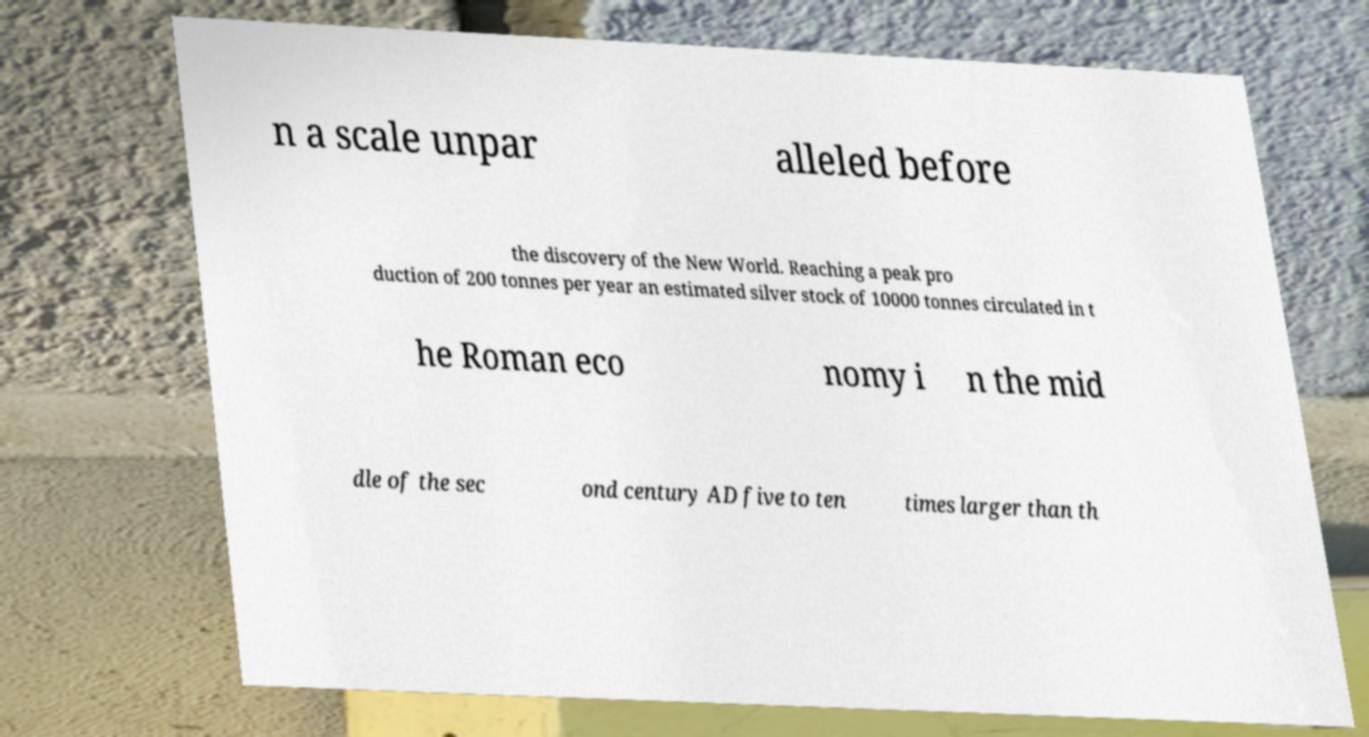There's text embedded in this image that I need extracted. Can you transcribe it verbatim? n a scale unpar alleled before the discovery of the New World. Reaching a peak pro duction of 200 tonnes per year an estimated silver stock of 10000 tonnes circulated in t he Roman eco nomy i n the mid dle of the sec ond century AD five to ten times larger than th 